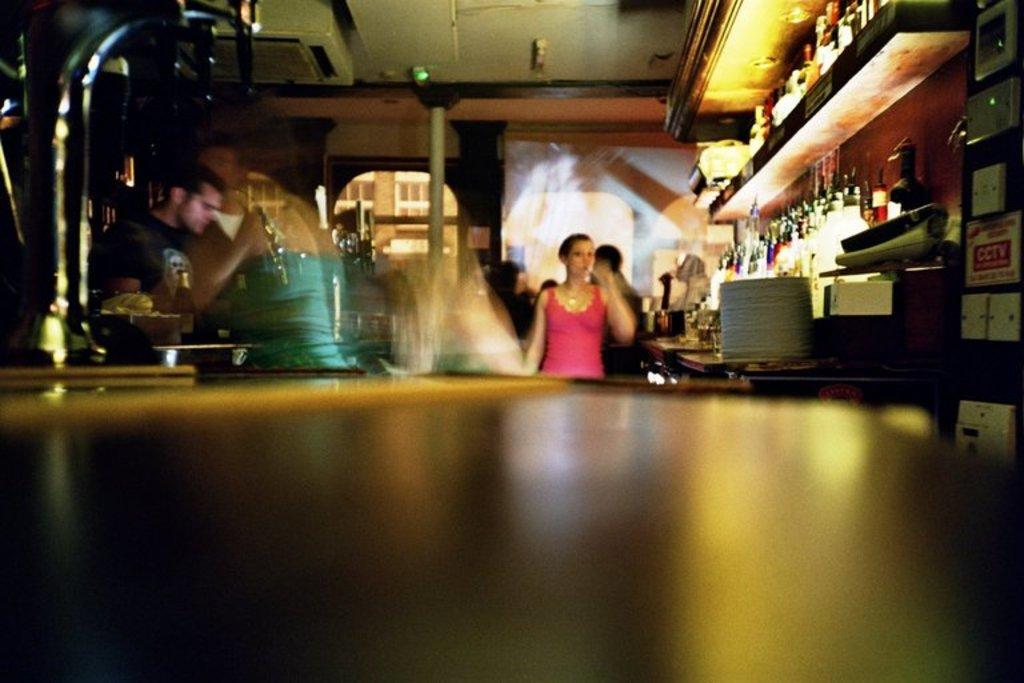How would you summarize this image in a sentence or two? In this image we can see there are persons standing. And there are racks and bottles in it. At the side there is a board, box and a few objects. At the back there is a screen. At the top there is an object attached to it. 